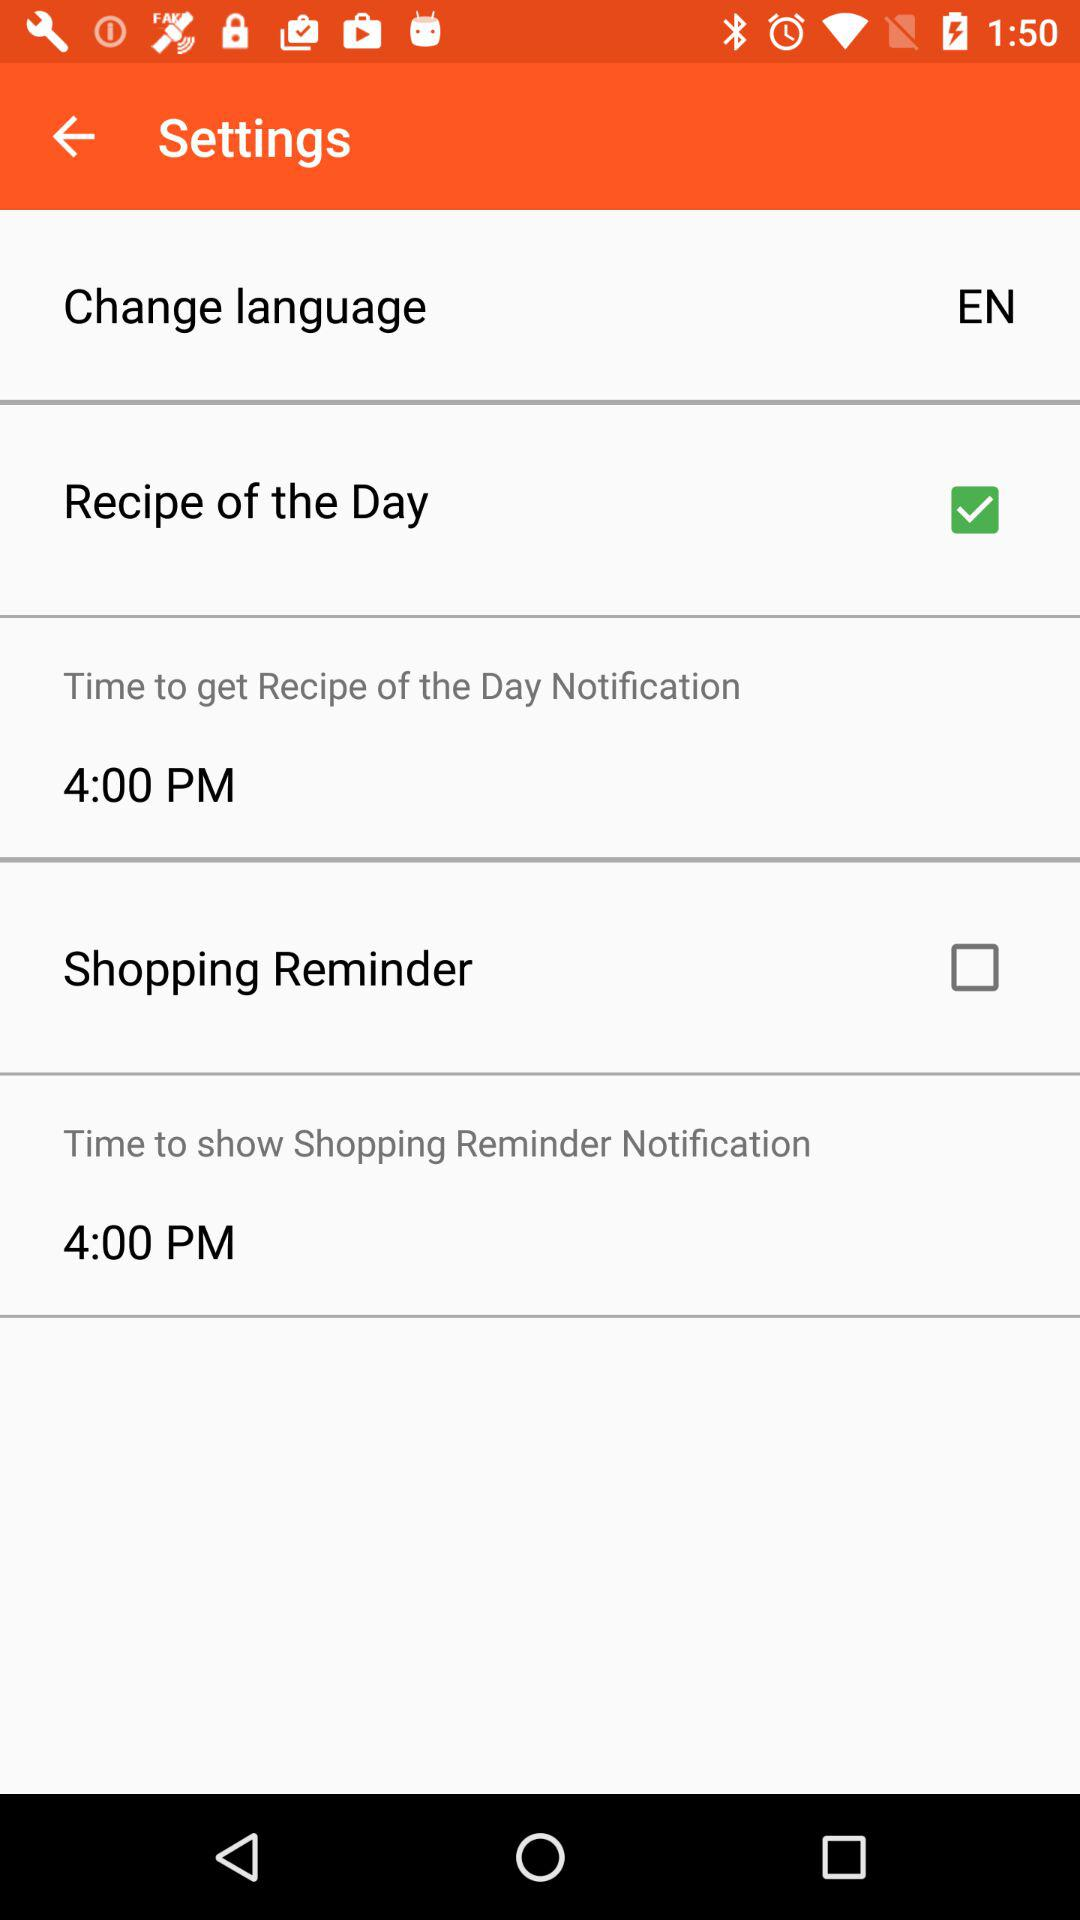What's the status of "Recipe of the Day"? The status of "Recipe of the Day" is "on". 